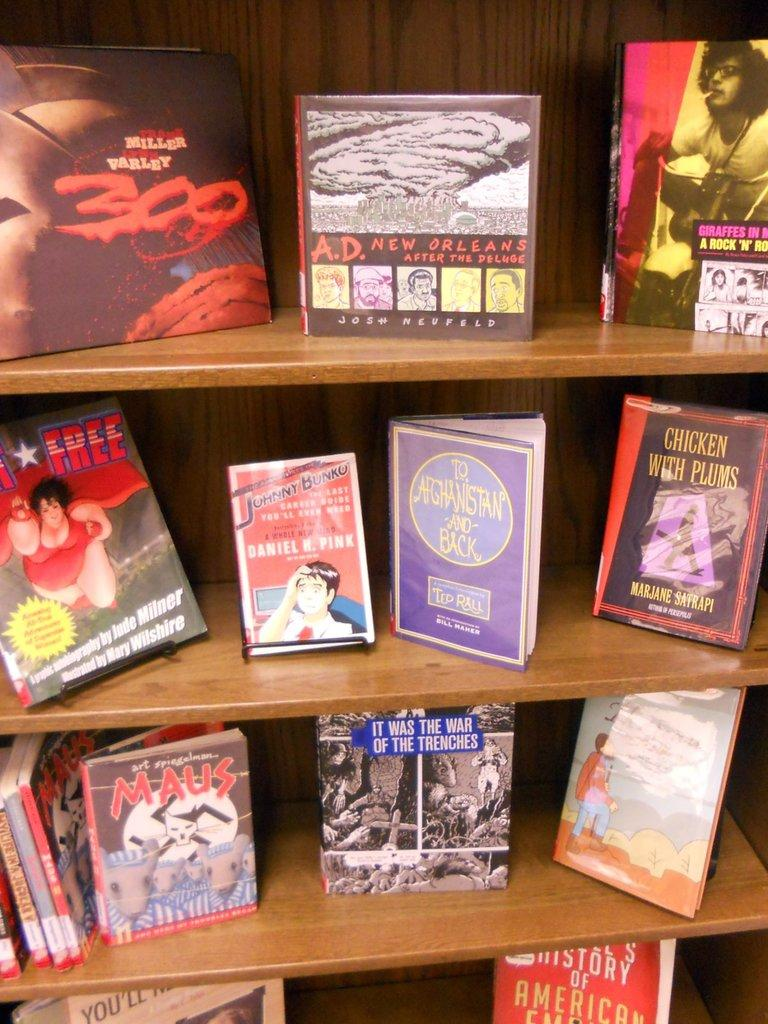Provide a one-sentence caption for the provided image. Chicken with Plums is one of the books on shelves with many. 